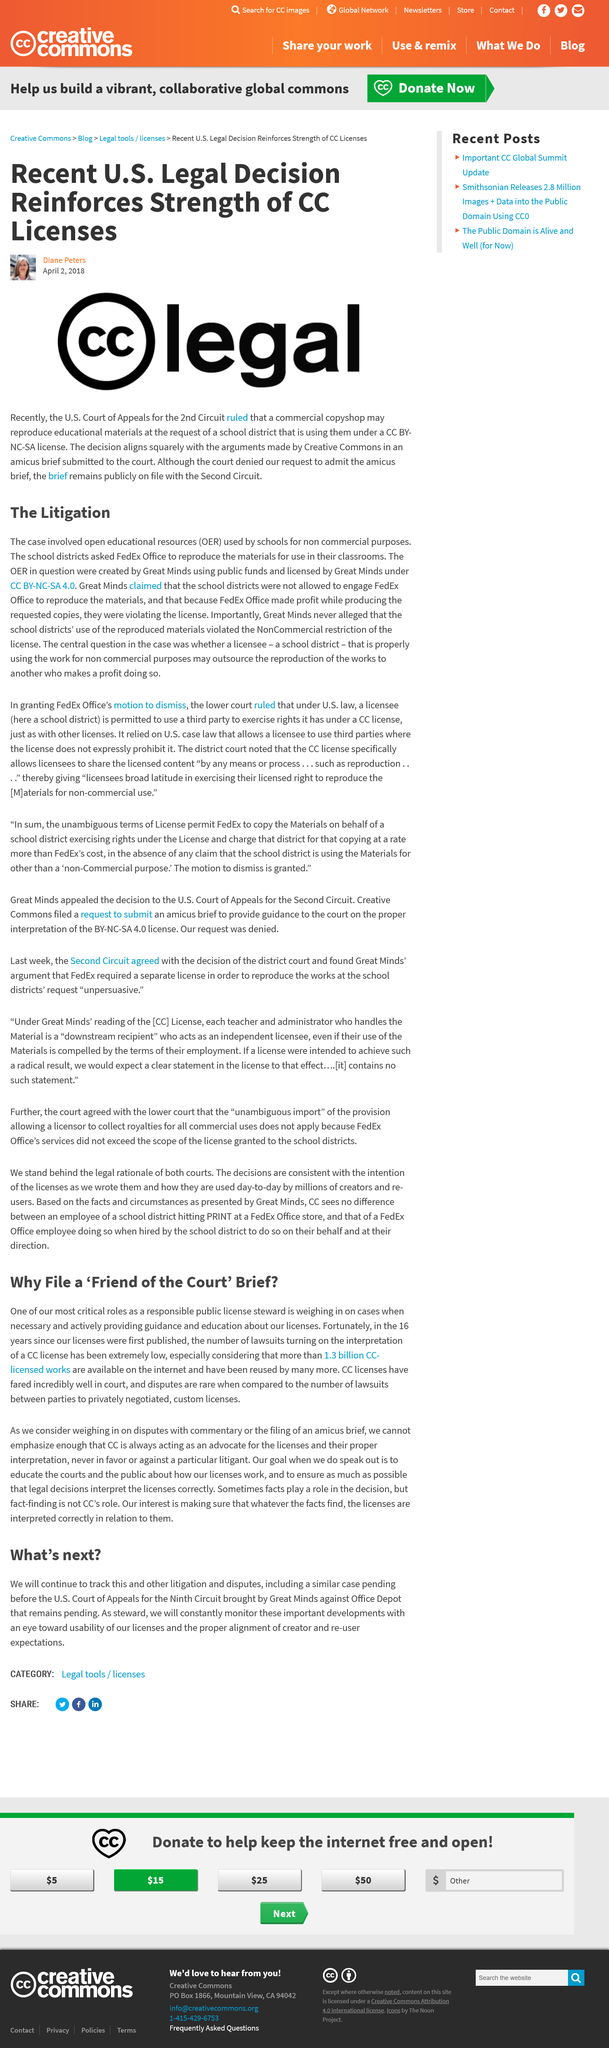Outline some significant characteristics in this image. The Creative Commons made arguments that were in alignment with the decision of the court. There are over 1.3 billion CC-licensed works available on the internet. As a responsible public license steward, one of the most critical roles is weighing in on cases and providing guidance and education about licenses when necessary. The brief that is publicly available remains with the Second Circuit. For 16 years, our licenses have been in publication. 